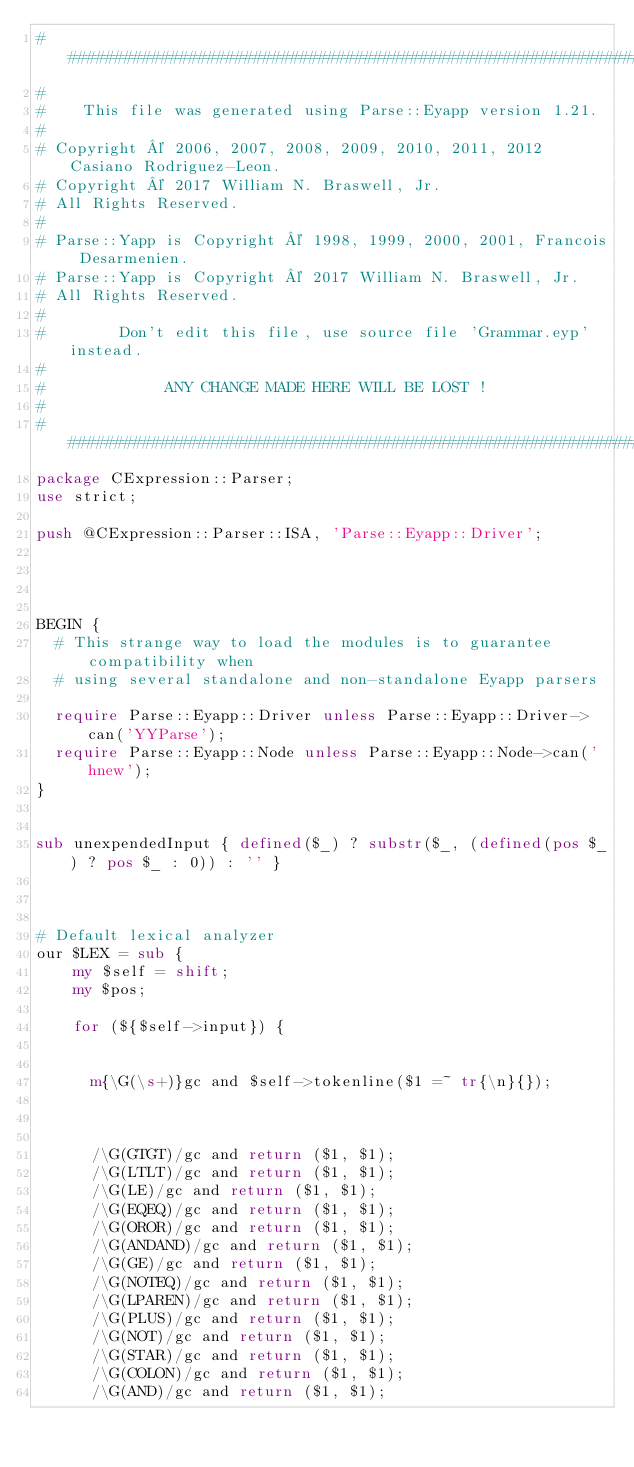<code> <loc_0><loc_0><loc_500><loc_500><_Perl_>########################################################################################
#
#    This file was generated using Parse::Eyapp version 1.21.
#
# Copyright © 2006, 2007, 2008, 2009, 2010, 2011, 2012 Casiano Rodriguez-Leon.
# Copyright © 2017 William N. Braswell, Jr.
# All Rights Reserved.
#
# Parse::Yapp is Copyright © 1998, 1999, 2000, 2001, Francois Desarmenien.
# Parse::Yapp is Copyright © 2017 William N. Braswell, Jr.
# All Rights Reserved.
#
#        Don't edit this file, use source file 'Grammar.eyp' instead.
#
#             ANY CHANGE MADE HERE WILL BE LOST !
#
########################################################################################
package CExpression::Parser;
use strict;

push @CExpression::Parser::ISA, 'Parse::Eyapp::Driver';




BEGIN {
  # This strange way to load the modules is to guarantee compatibility when
  # using several standalone and non-standalone Eyapp parsers

  require Parse::Eyapp::Driver unless Parse::Eyapp::Driver->can('YYParse');
  require Parse::Eyapp::Node unless Parse::Eyapp::Node->can('hnew'); 
}
  

sub unexpendedInput { defined($_) ? substr($_, (defined(pos $_) ? pos $_ : 0)) : '' }



# Default lexical analyzer
our $LEX = sub {
    my $self = shift;
    my $pos;

    for (${$self->input}) {
      

      m{\G(\s+)}gc and $self->tokenline($1 =~ tr{\n}{});

      

      /\G(GTGT)/gc and return ($1, $1);
      /\G(LTLT)/gc and return ($1, $1);
      /\G(LE)/gc and return ($1, $1);
      /\G(EQEQ)/gc and return ($1, $1);
      /\G(OROR)/gc and return ($1, $1);
      /\G(ANDAND)/gc and return ($1, $1);
      /\G(GE)/gc and return ($1, $1);
      /\G(NOTEQ)/gc and return ($1, $1);
      /\G(LPAREN)/gc and return ($1, $1);
      /\G(PLUS)/gc and return ($1, $1);
      /\G(NOT)/gc and return ($1, $1);
      /\G(STAR)/gc and return ($1, $1);
      /\G(COLON)/gc and return ($1, $1);
      /\G(AND)/gc and return ($1, $1);</code> 